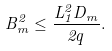Convert formula to latex. <formula><loc_0><loc_0><loc_500><loc_500>B _ { m } ^ { 2 } \leq \frac { L _ { 1 } ^ { 2 } D _ { m } } { 2 q } .</formula> 